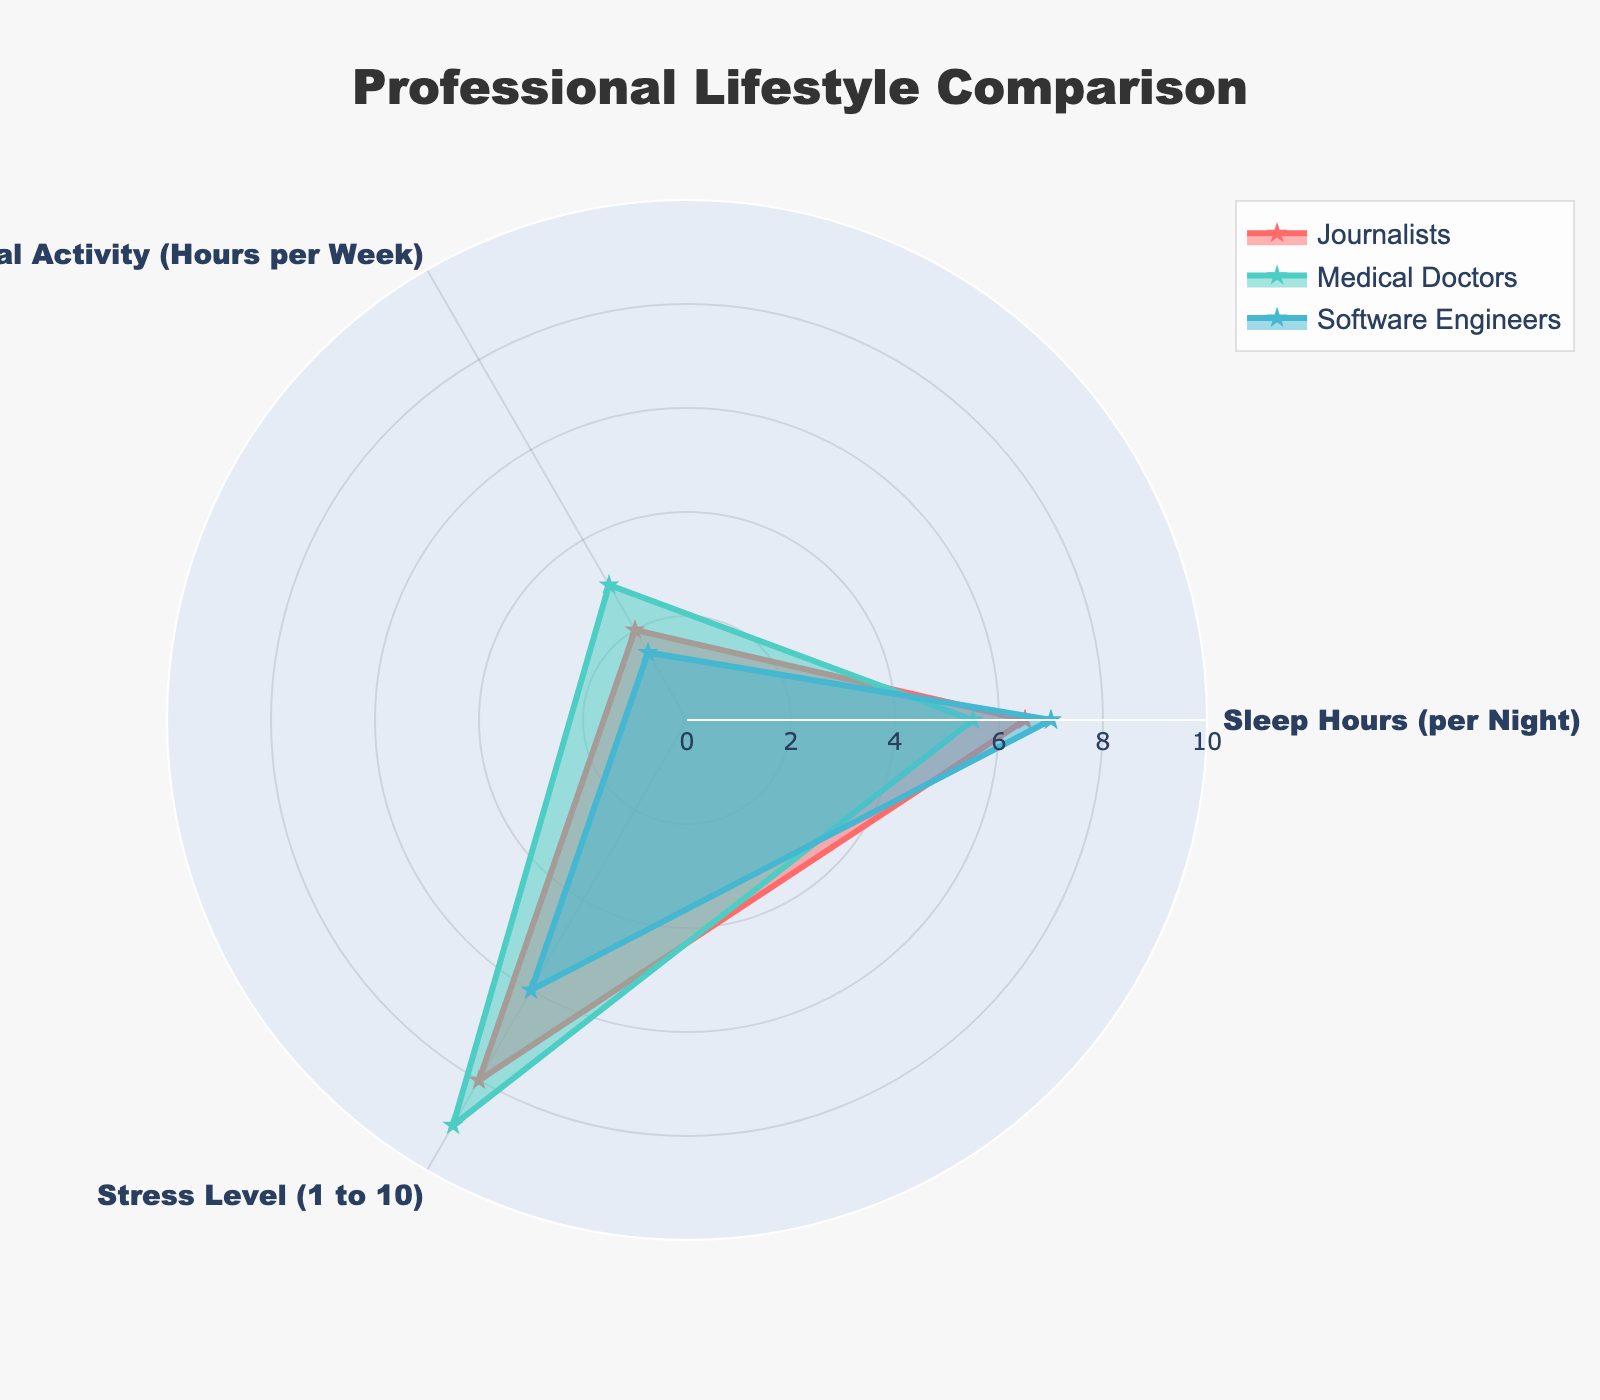What is the title of the radar chart? The title of the radar chart is located at the top-center of the figure. It is intended to provide a brief description of what the chart represents.
Answer: Professional Lifestyle Comparison How many professional groups are displayed in the chart? The chart includes data for less than 4 groups, and each group is represented by a different colored line. By counting the lines, we can determine the number of groups.
Answer: 3 Which professional group has the highest average value across all categories? To determine the group with the highest average value, we need to calculate the average for each group. This can be done by summing the values for Sleep Hours, Physical Activity, and Stress Level, and dividing by 3. For Journalists: (6.5 + 2 + 8)/3 = 5.5. For Medical Doctors: (5.5 + 3 + 9)/3 = 5.83. For Software Engineers: (7 + 1.5 + 6)/3 = 4.83.
Answer: Medical Doctors Which group exhibits the least physical activity? By looking at the 'Physical Activity' axis on the radar chart, we can identify which group has the smallest value.
Answer: Software Engineers What is the total Sleep Hours per Night for all displayed professional groups combined? To find the total Sleep Hours, sum the sleep hours for each of the groups displayed. For Journalists: 6.5 hours; For Medical Doctors: 5.5 hours; For Software Engineers: 7 hours. Therefore: 6.5 + 5.5 + 7 = 19 hours.
Answer: 19 hours Which group has a higher stress level, Journalists or Medical Doctors? By comparing the points on the 'Stress Level' axis for Journalists and Medical Doctors, we see Journalists have a stress level of 8, while Medical Doctors have a stress level of 9.
Answer: Medical Doctors What is the difference in Sleep Hours per Night between Journalists and Software Engineers? The sleep hours for Journalists is 6.5 and for Software Engineers is 7. Subtract the two values: 7 - 6.5 = 0.5.
Answer: 0.5 hours Among the groups displayed, which one appears to have the most balanced lifestyle in terms of the three categories? A balanced lifestyle would mean relatively similar values across Sleep Hours, Physical Activity, and Stress Level. Visually, the group with a more regular, similar radius on each axis is the most balanced. Among the groups displayed, Software Engineers have more evenly distributed values.
Answer: Software Engineers What is the approximate range on the radial axis? The radial axis displays the range of values for the data. Observing the axis labels and gridline intervals, the approximate range can be seen.
Answer: 0 to 10 